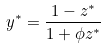<formula> <loc_0><loc_0><loc_500><loc_500>y ^ { * } = \frac { 1 - z ^ { * } } { 1 + \phi z ^ { * } }</formula> 